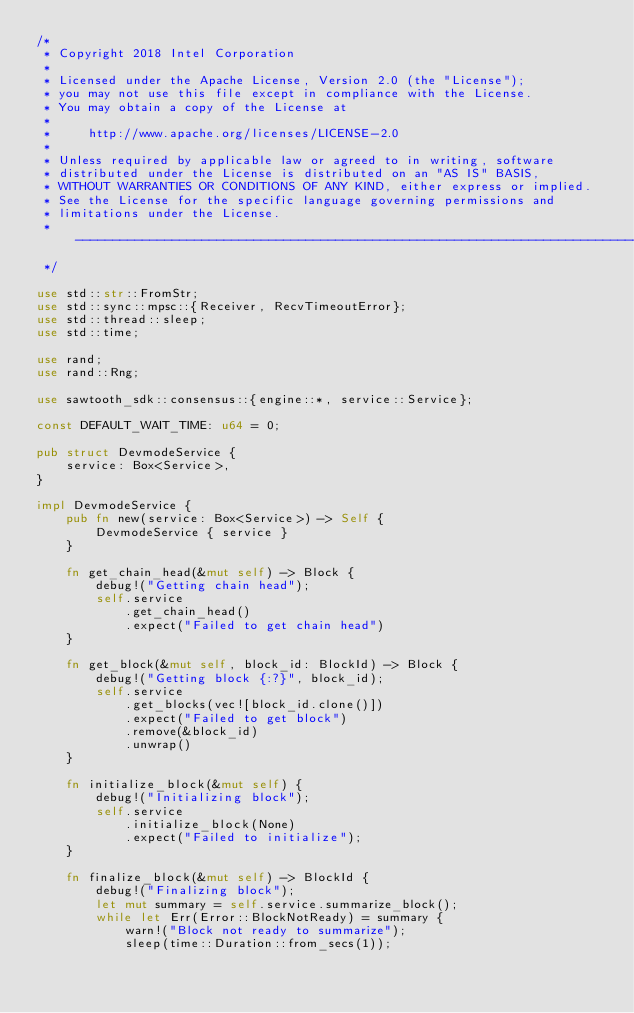<code> <loc_0><loc_0><loc_500><loc_500><_Rust_>/*
 * Copyright 2018 Intel Corporation
 *
 * Licensed under the Apache License, Version 2.0 (the "License");
 * you may not use this file except in compliance with the License.
 * You may obtain a copy of the License at
 *
 *     http://www.apache.org/licenses/LICENSE-2.0
 *
 * Unless required by applicable law or agreed to in writing, software
 * distributed under the License is distributed on an "AS IS" BASIS,
 * WITHOUT WARRANTIES OR CONDITIONS OF ANY KIND, either express or implied.
 * See the License for the specific language governing permissions and
 * limitations under the License.
 * ------------------------------------------------------------------------------
 */

use std::str::FromStr;
use std::sync::mpsc::{Receiver, RecvTimeoutError};
use std::thread::sleep;
use std::time;

use rand;
use rand::Rng;

use sawtooth_sdk::consensus::{engine::*, service::Service};

const DEFAULT_WAIT_TIME: u64 = 0;

pub struct DevmodeService {
    service: Box<Service>,
}

impl DevmodeService {
    pub fn new(service: Box<Service>) -> Self {
        DevmodeService { service }
    }

    fn get_chain_head(&mut self) -> Block {
        debug!("Getting chain head");
        self.service
            .get_chain_head()
            .expect("Failed to get chain head")
    }

    fn get_block(&mut self, block_id: BlockId) -> Block {
        debug!("Getting block {:?}", block_id);
        self.service
            .get_blocks(vec![block_id.clone()])
            .expect("Failed to get block")
            .remove(&block_id)
            .unwrap()
    }

    fn initialize_block(&mut self) {
        debug!("Initializing block");
        self.service
            .initialize_block(None)
            .expect("Failed to initialize");
    }

    fn finalize_block(&mut self) -> BlockId {
        debug!("Finalizing block");
        let mut summary = self.service.summarize_block();
        while let Err(Error::BlockNotReady) = summary {
            warn!("Block not ready to summarize");
            sleep(time::Duration::from_secs(1));</code> 